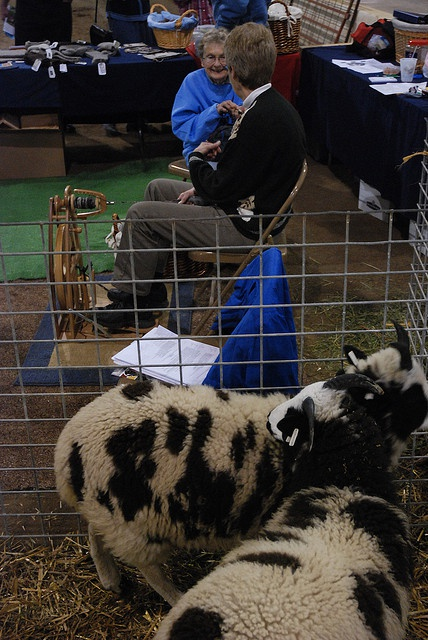Describe the objects in this image and their specific colors. I can see sheep in gray, black, and darkgray tones, sheep in gray, black, and tan tones, people in gray and black tones, dining table in gray, black, navy, and darkgray tones, and people in gray, blue, black, and navy tones in this image. 